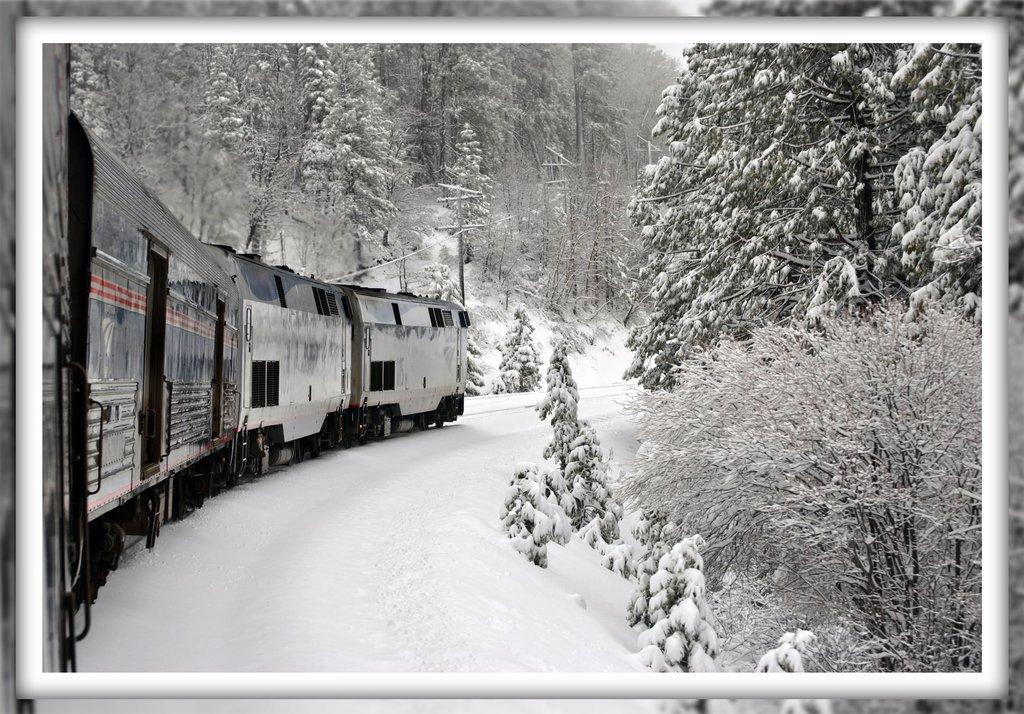What is the main subject of the image? The main subject of the image is a train. Where is the train located in the image? The train is standing on a railway track. What is the condition of the ground in the image? The ground is covered with snow. What type of vegetation can be seen in the image? There are trees in the image. How are the trees affected by the snow in the image? The trees are covered with snow. What type of sofa can be seen in the image? There is no sofa present in the image. What songs are being played by the train in the image? The image does not depict any songs being played by the train. 